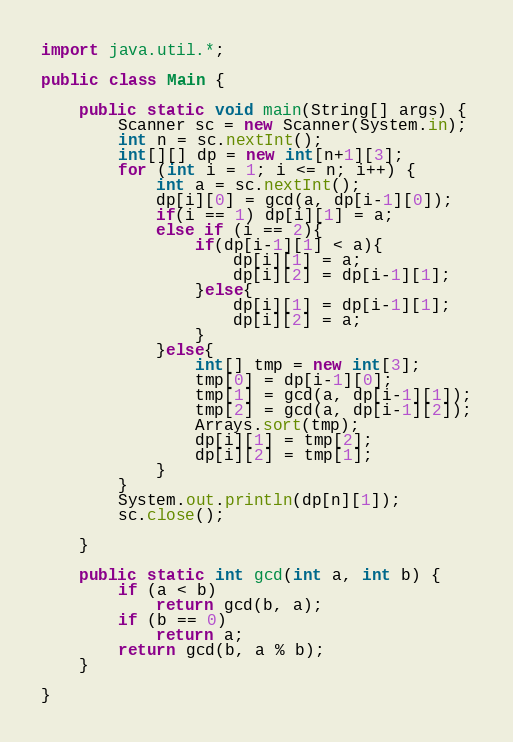<code> <loc_0><loc_0><loc_500><loc_500><_Java_>import java.util.*;

public class Main {

    public static void main(String[] args) {
        Scanner sc = new Scanner(System.in);
        int n = sc.nextInt();
        int[][] dp = new int[n+1][3];
        for (int i = 1; i <= n; i++) {
            int a = sc.nextInt();
            dp[i][0] = gcd(a, dp[i-1][0]);
            if(i == 1) dp[i][1] = a;
            else if (i == 2){
                if(dp[i-1][1] < a){
                    dp[i][1] = a;
                    dp[i][2] = dp[i-1][1];
                }else{
                    dp[i][1] = dp[i-1][1];
                    dp[i][2] = a;
                }
            }else{
                int[] tmp = new int[3];
                tmp[0] = dp[i-1][0];
                tmp[1] = gcd(a, dp[i-1][1]);
                tmp[2] = gcd(a, dp[i-1][2]);
                Arrays.sort(tmp);
                dp[i][1] = tmp[2];
                dp[i][2] = tmp[1];
            }
        }
        System.out.println(dp[n][1]);
        sc.close();

    }

    public static int gcd(int a, int b) {
        if (a < b)
            return gcd(b, a);
        if (b == 0)
            return a;
        return gcd(b, a % b);
    }

}
</code> 